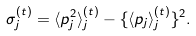<formula> <loc_0><loc_0><loc_500><loc_500>\sigma _ { j } ^ { ( t ) } = \langle p _ { j } ^ { 2 } \rangle _ { j } ^ { ( t ) } - \{ \langle p _ { j } \rangle _ { j } ^ { ( t ) } \} ^ { 2 } .</formula> 